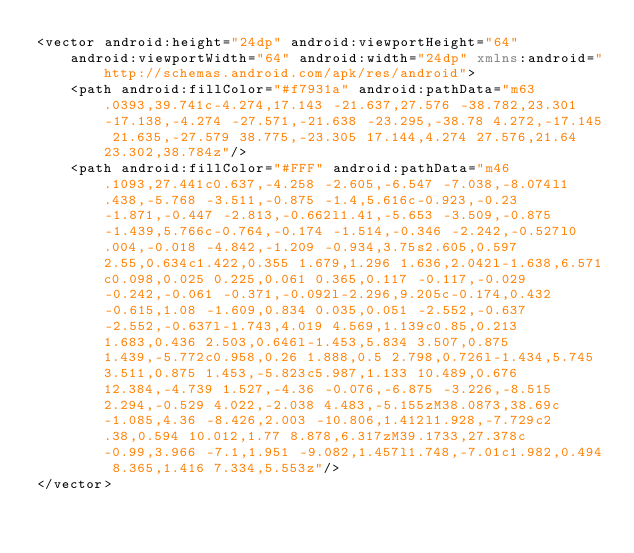<code> <loc_0><loc_0><loc_500><loc_500><_XML_><vector android:height="24dp" android:viewportHeight="64"
    android:viewportWidth="64" android:width="24dp" xmlns:android="http://schemas.android.com/apk/res/android">
    <path android:fillColor="#f7931a" android:pathData="m63.0393,39.741c-4.274,17.143 -21.637,27.576 -38.782,23.301 -17.138,-4.274 -27.571,-21.638 -23.295,-38.78 4.272,-17.145 21.635,-27.579 38.775,-23.305 17.144,4.274 27.576,21.64 23.302,38.784z"/>
    <path android:fillColor="#FFF" android:pathData="m46.1093,27.441c0.637,-4.258 -2.605,-6.547 -7.038,-8.074l1.438,-5.768 -3.511,-0.875 -1.4,5.616c-0.923,-0.23 -1.871,-0.447 -2.813,-0.662l1.41,-5.653 -3.509,-0.875 -1.439,5.766c-0.764,-0.174 -1.514,-0.346 -2.242,-0.527l0.004,-0.018 -4.842,-1.209 -0.934,3.75s2.605,0.597 2.55,0.634c1.422,0.355 1.679,1.296 1.636,2.042l-1.638,6.571c0.098,0.025 0.225,0.061 0.365,0.117 -0.117,-0.029 -0.242,-0.061 -0.371,-0.092l-2.296,9.205c-0.174,0.432 -0.615,1.08 -1.609,0.834 0.035,0.051 -2.552,-0.637 -2.552,-0.637l-1.743,4.019 4.569,1.139c0.85,0.213 1.683,0.436 2.503,0.646l-1.453,5.834 3.507,0.875 1.439,-5.772c0.958,0.26 1.888,0.5 2.798,0.726l-1.434,5.745 3.511,0.875 1.453,-5.823c5.987,1.133 10.489,0.676 12.384,-4.739 1.527,-4.36 -0.076,-6.875 -3.226,-8.515 2.294,-0.529 4.022,-2.038 4.483,-5.155zM38.0873,38.69c-1.085,4.36 -8.426,2.003 -10.806,1.412l1.928,-7.729c2.38,0.594 10.012,1.77 8.878,6.317zM39.1733,27.378c-0.99,3.966 -7.1,1.951 -9.082,1.457l1.748,-7.01c1.982,0.494 8.365,1.416 7.334,5.553z"/>
</vector>
</code> 